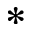Convert formula to latex. <formula><loc_0><loc_0><loc_500><loc_500>^ { * }</formula> 